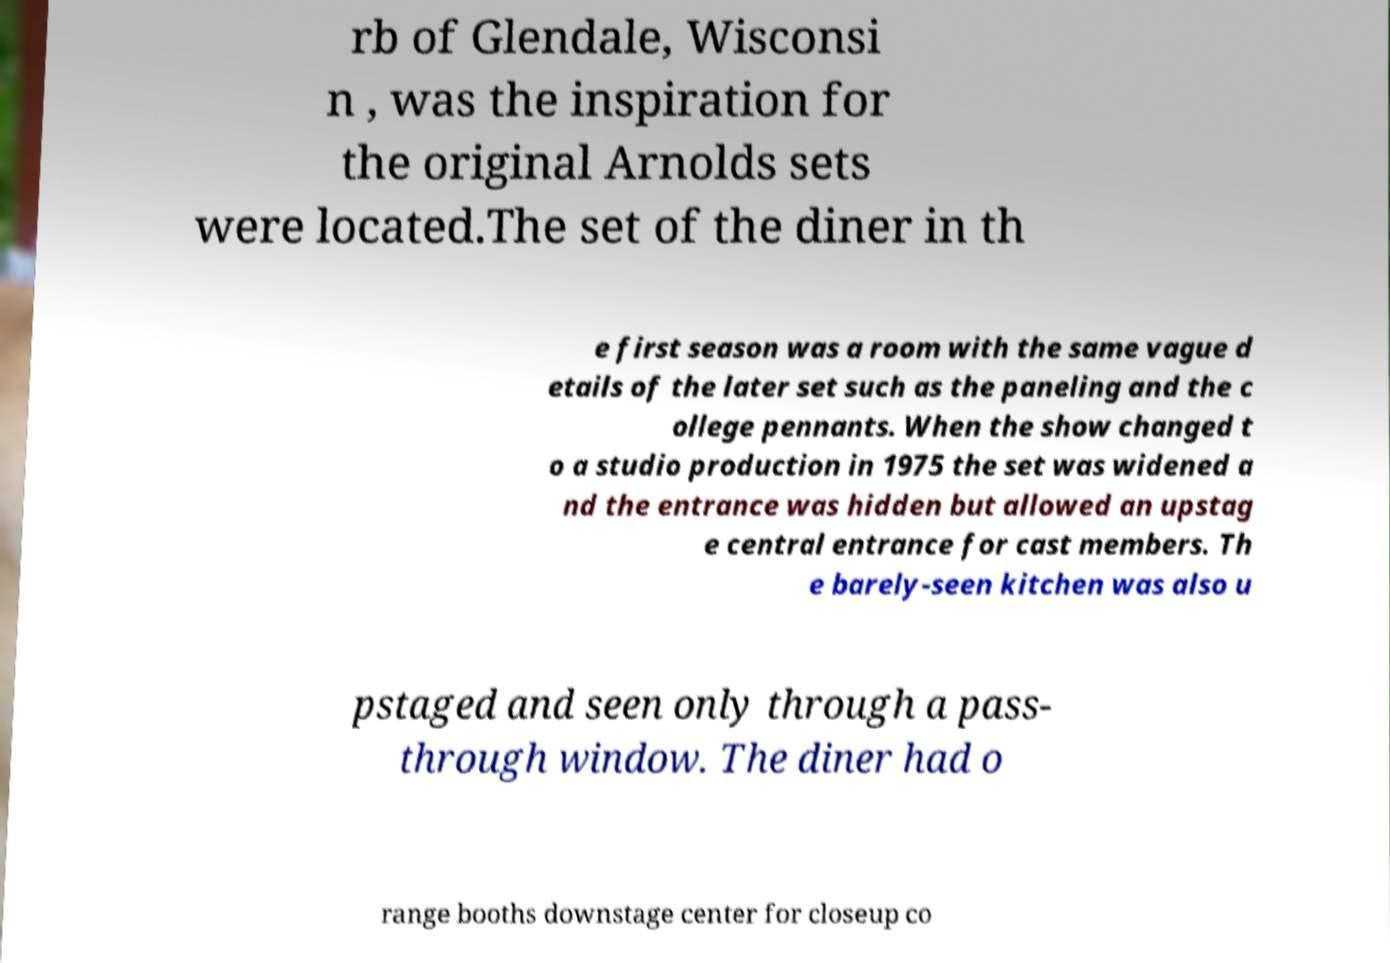Can you accurately transcribe the text from the provided image for me? rb of Glendale, Wisconsi n , was the inspiration for the original Arnolds sets were located.The set of the diner in th e first season was a room with the same vague d etails of the later set such as the paneling and the c ollege pennants. When the show changed t o a studio production in 1975 the set was widened a nd the entrance was hidden but allowed an upstag e central entrance for cast members. Th e barely-seen kitchen was also u pstaged and seen only through a pass- through window. The diner had o range booths downstage center for closeup co 